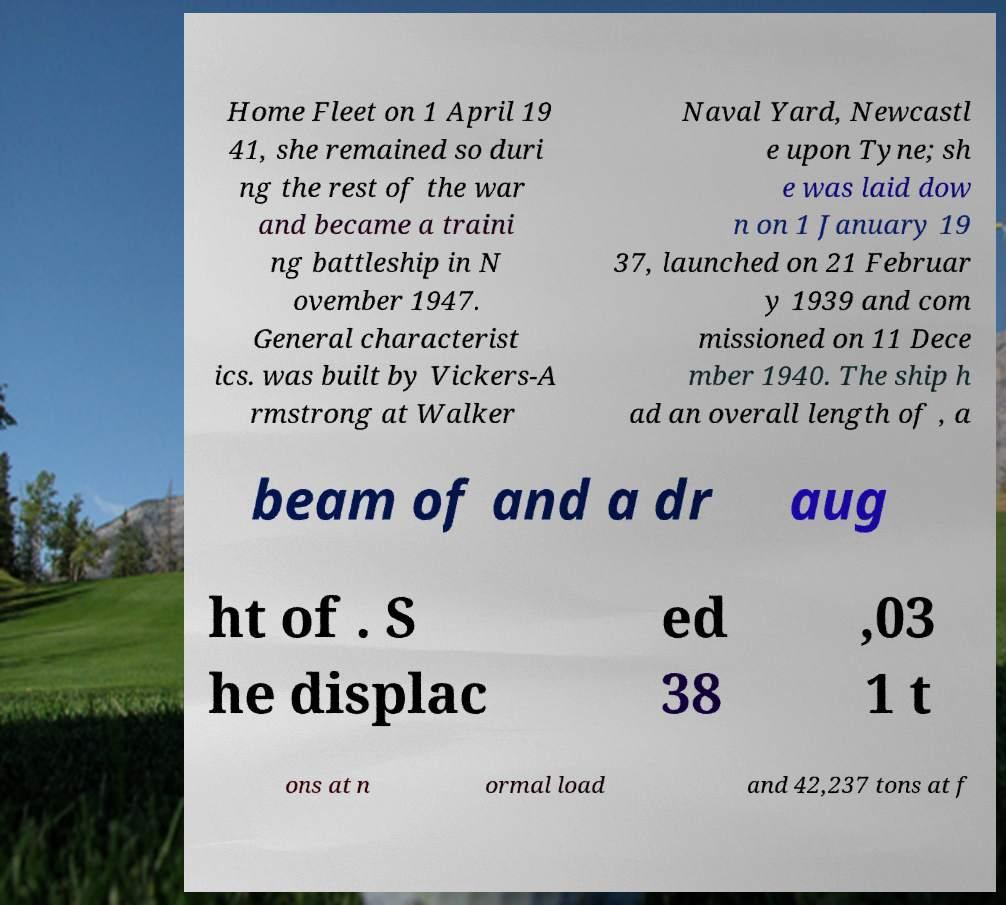Please identify and transcribe the text found in this image. Home Fleet on 1 April 19 41, she remained so duri ng the rest of the war and became a traini ng battleship in N ovember 1947. General characterist ics. was built by Vickers-A rmstrong at Walker Naval Yard, Newcastl e upon Tyne; sh e was laid dow n on 1 January 19 37, launched on 21 Februar y 1939 and com missioned on 11 Dece mber 1940. The ship h ad an overall length of , a beam of and a dr aug ht of . S he displac ed 38 ,03 1 t ons at n ormal load and 42,237 tons at f 